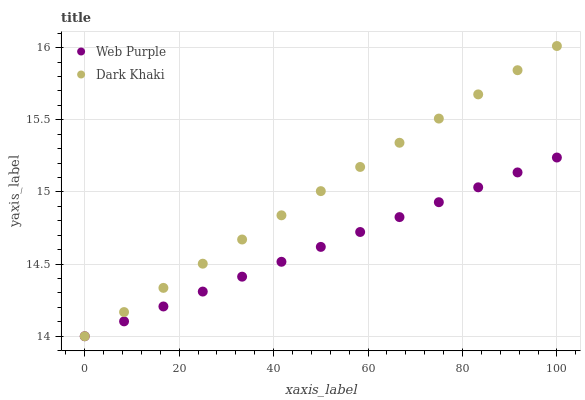Does Web Purple have the minimum area under the curve?
Answer yes or no. Yes. Does Dark Khaki have the maximum area under the curve?
Answer yes or no. Yes. Does Web Purple have the maximum area under the curve?
Answer yes or no. No. Is Dark Khaki the smoothest?
Answer yes or no. Yes. Is Web Purple the roughest?
Answer yes or no. Yes. Is Web Purple the smoothest?
Answer yes or no. No. Does Dark Khaki have the lowest value?
Answer yes or no. Yes. Does Dark Khaki have the highest value?
Answer yes or no. Yes. Does Web Purple have the highest value?
Answer yes or no. No. Does Dark Khaki intersect Web Purple?
Answer yes or no. Yes. Is Dark Khaki less than Web Purple?
Answer yes or no. No. Is Dark Khaki greater than Web Purple?
Answer yes or no. No. 